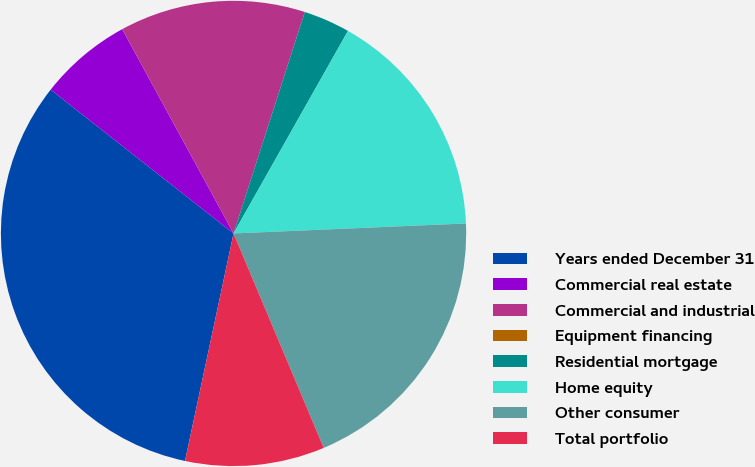<chart> <loc_0><loc_0><loc_500><loc_500><pie_chart><fcel>Years ended December 31<fcel>Commercial real estate<fcel>Commercial and industrial<fcel>Equipment financing<fcel>Residential mortgage<fcel>Home equity<fcel>Other consumer<fcel>Total portfolio<nl><fcel>32.26%<fcel>6.45%<fcel>12.9%<fcel>0.0%<fcel>3.23%<fcel>16.13%<fcel>19.35%<fcel>9.68%<nl></chart> 